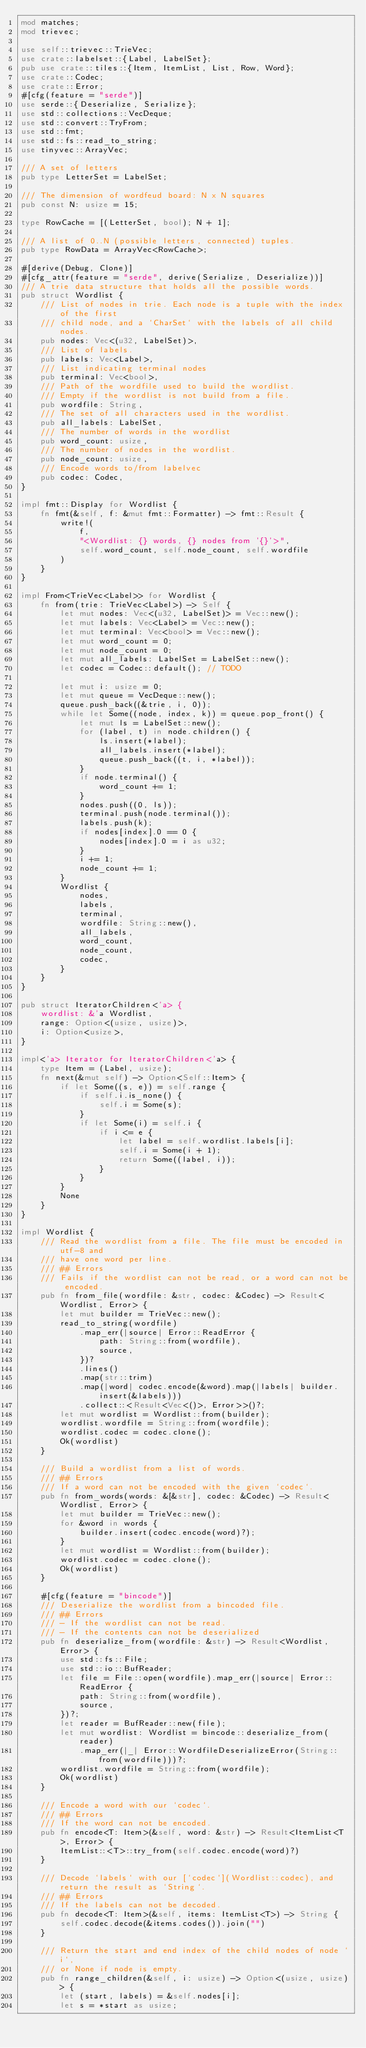Convert code to text. <code><loc_0><loc_0><loc_500><loc_500><_Rust_>mod matches;
mod trievec;

use self::trievec::TrieVec;
use crate::labelset::{Label, LabelSet};
pub use crate::tiles::{Item, ItemList, List, Row, Word};
use crate::Codec;
use crate::Error;
#[cfg(feature = "serde")]
use serde::{Deserialize, Serialize};
use std::collections::VecDeque;
use std::convert::TryFrom;
use std::fmt;
use std::fs::read_to_string;
use tinyvec::ArrayVec;

/// A set of letters
pub type LetterSet = LabelSet;

/// The dimension of wordfeud board: N x N squares
pub const N: usize = 15;

type RowCache = [(LetterSet, bool); N + 1];

/// A list of 0..N (possible letters, connected) tuples.
pub type RowData = ArrayVec<RowCache>;

#[derive(Debug, Clone)]
#[cfg_attr(feature = "serde", derive(Serialize, Deserialize))]
/// A trie data structure that holds all the possible words.
pub struct Wordlist {
    /// List of nodes in trie. Each node is a tuple with the index of the first
    /// child node, and a `CharSet` with the labels of all child nodes.
    pub nodes: Vec<(u32, LabelSet)>,
    /// List of labels.
    pub labels: Vec<Label>,
    /// List indicating terminal nodes
    pub terminal: Vec<bool>,
    /// Path of the wordfile used to build the wordlist.
    /// Empty if the wordlist is not build from a file.
    pub wordfile: String,
    /// The set of all characters used in the wordlist.
    pub all_labels: LabelSet,
    /// The number of words in the wordlist
    pub word_count: usize,
    /// The number of nodes in the wordlist.
    pub node_count: usize,
    /// Encode words to/from labelvec
    pub codec: Codec,
}

impl fmt::Display for Wordlist {
    fn fmt(&self, f: &mut fmt::Formatter) -> fmt::Result {
        write!(
            f,
            "<Wordlist: {} words, {} nodes from '{}'>",
            self.word_count, self.node_count, self.wordfile
        )
    }
}

impl From<TrieVec<Label>> for Wordlist {
    fn from(trie: TrieVec<Label>) -> Self {
        let mut nodes: Vec<(u32, LabelSet)> = Vec::new();
        let mut labels: Vec<Label> = Vec::new();
        let mut terminal: Vec<bool> = Vec::new();
        let mut word_count = 0;
        let mut node_count = 0;
        let mut all_labels: LabelSet = LabelSet::new();
        let codec = Codec::default(); // TODO

        let mut i: usize = 0;
        let mut queue = VecDeque::new();
        queue.push_back((&trie, i, 0));
        while let Some((node, index, k)) = queue.pop_front() {
            let mut ls = LabelSet::new();
            for (label, t) in node.children() {
                ls.insert(*label);
                all_labels.insert(*label);
                queue.push_back((t, i, *label));
            }
            if node.terminal() {
                word_count += 1;
            }
            nodes.push((0, ls));
            terminal.push(node.terminal());
            labels.push(k);
            if nodes[index].0 == 0 {
                nodes[index].0 = i as u32;
            }
            i += 1;
            node_count += 1;
        }
        Wordlist {
            nodes,
            labels,
            terminal,
            wordfile: String::new(),
            all_labels,
            word_count,
            node_count,
            codec,
        }
    }
}

pub struct IteratorChildren<'a> {
    wordlist: &'a Wordlist,
    range: Option<(usize, usize)>,
    i: Option<usize>,
}

impl<'a> Iterator for IteratorChildren<'a> {
    type Item = (Label, usize);
    fn next(&mut self) -> Option<Self::Item> {
        if let Some((s, e)) = self.range {
            if self.i.is_none() {
                self.i = Some(s);
            }
            if let Some(i) = self.i {
                if i <= e {
                    let label = self.wordlist.labels[i];
                    self.i = Some(i + 1);
                    return Some((label, i));
                }
            }
        }
        None
    }
}

impl Wordlist {
    /// Read the wordlist from a file. The file must be encoded in utf-8 and
    /// have one word per line.
    /// ## Errors
    /// Fails if the wordlist can not be read, or a word can not be encoded.
    pub fn from_file(wordfile: &str, codec: &Codec) -> Result<Wordlist, Error> {
        let mut builder = TrieVec::new();
        read_to_string(wordfile)
            .map_err(|source| Error::ReadError {
                path: String::from(wordfile),
                source,
            })?
            .lines()
            .map(str::trim)
            .map(|word| codec.encode(&word).map(|labels| builder.insert(&labels)))
            .collect::<Result<Vec<()>, Error>>()?;
        let mut wordlist = Wordlist::from(builder);
        wordlist.wordfile = String::from(wordfile);
        wordlist.codec = codec.clone();
        Ok(wordlist)
    }

    /// Build a wordlist from a list of words.
    /// ## Errors
    /// If a word can not be encoded with the given `codec`.
    pub fn from_words(words: &[&str], codec: &Codec) -> Result<Wordlist, Error> {
        let mut builder = TrieVec::new();
        for &word in words {
            builder.insert(codec.encode(word)?);
        }
        let mut wordlist = Wordlist::from(builder);
        wordlist.codec = codec.clone();
        Ok(wordlist)
    }

    #[cfg(feature = "bincode")]
    /// Deserialize the wordlist from a bincoded file.
    /// ## Errors
    /// - If the wordlist can not be read.
    /// - If the contents can not be deserialized
    pub fn deserialize_from(wordfile: &str) -> Result<Wordlist, Error> {
        use std::fs::File;
        use std::io::BufReader;
        let file = File::open(wordfile).map_err(|source| Error::ReadError {
            path: String::from(wordfile),
            source,
        })?;
        let reader = BufReader::new(file);
        let mut wordlist: Wordlist = bincode::deserialize_from(reader)
            .map_err(|_| Error::WordfileDeserializeError(String::from(wordfile)))?;
        wordlist.wordfile = String::from(wordfile);
        Ok(wordlist)
    }

    /// Encode a word with our `codec`.
    /// ## Errors
    /// If the word can not be encoded.
    pub fn encode<T: Item>(&self, word: &str) -> Result<ItemList<T>, Error> {
        ItemList::<T>::try_from(self.codec.encode(word)?)
    }

    /// Decode `labels` with our [`codec`](Wordlist::codec), and return the result as `String`.
    /// ## Errors
    /// If the labels can not be decoded.
    pub fn decode<T: Item>(&self, items: ItemList<T>) -> String {
        self.codec.decode(&items.codes()).join("")
    }

    /// Return the start and end index of the child nodes of node `i`,
    /// or None if node is empty.
    pub fn range_children(&self, i: usize) -> Option<(usize, usize)> {
        let (start, labels) = &self.nodes[i];
        let s = *start as usize;</code> 